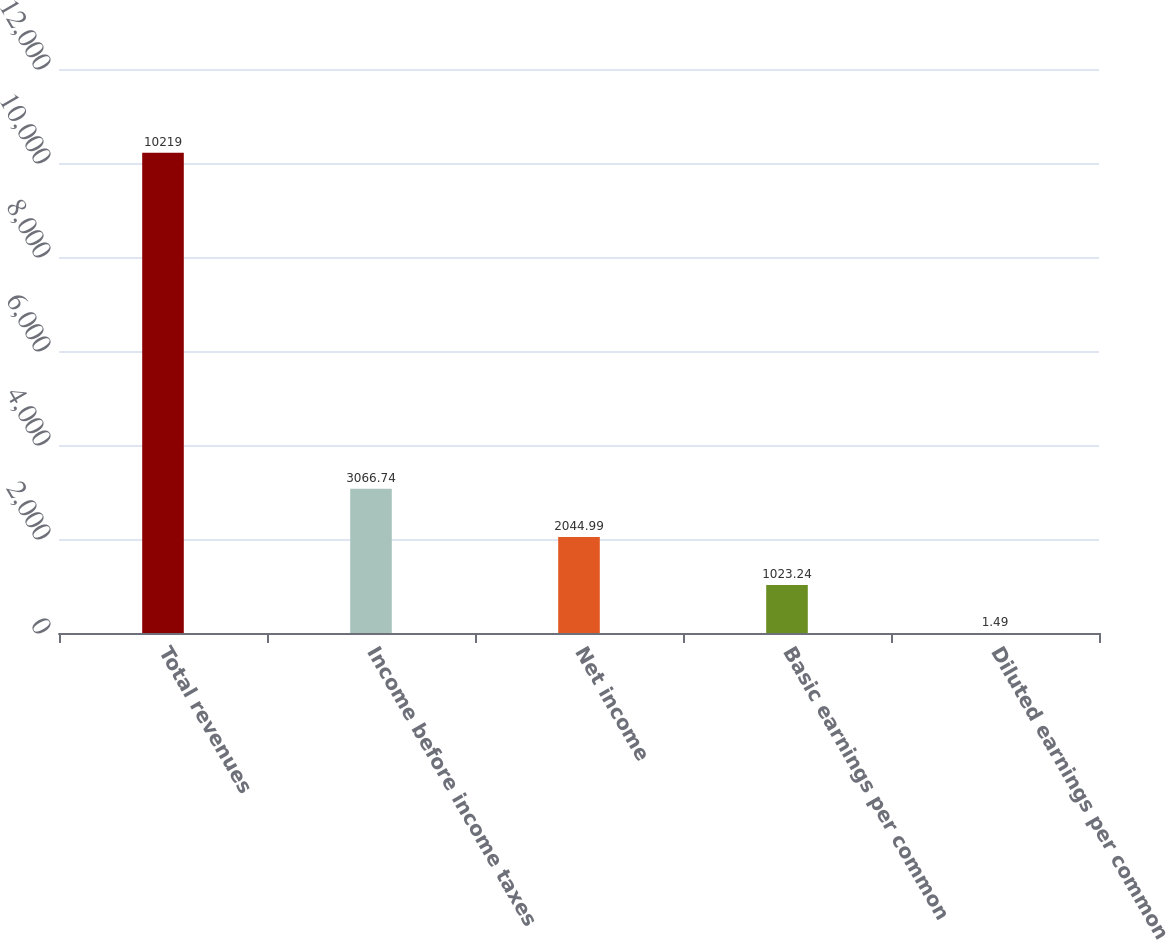Convert chart to OTSL. <chart><loc_0><loc_0><loc_500><loc_500><bar_chart><fcel>Total revenues<fcel>Income before income taxes<fcel>Net income<fcel>Basic earnings per common<fcel>Diluted earnings per common<nl><fcel>10219<fcel>3066.74<fcel>2044.99<fcel>1023.24<fcel>1.49<nl></chart> 